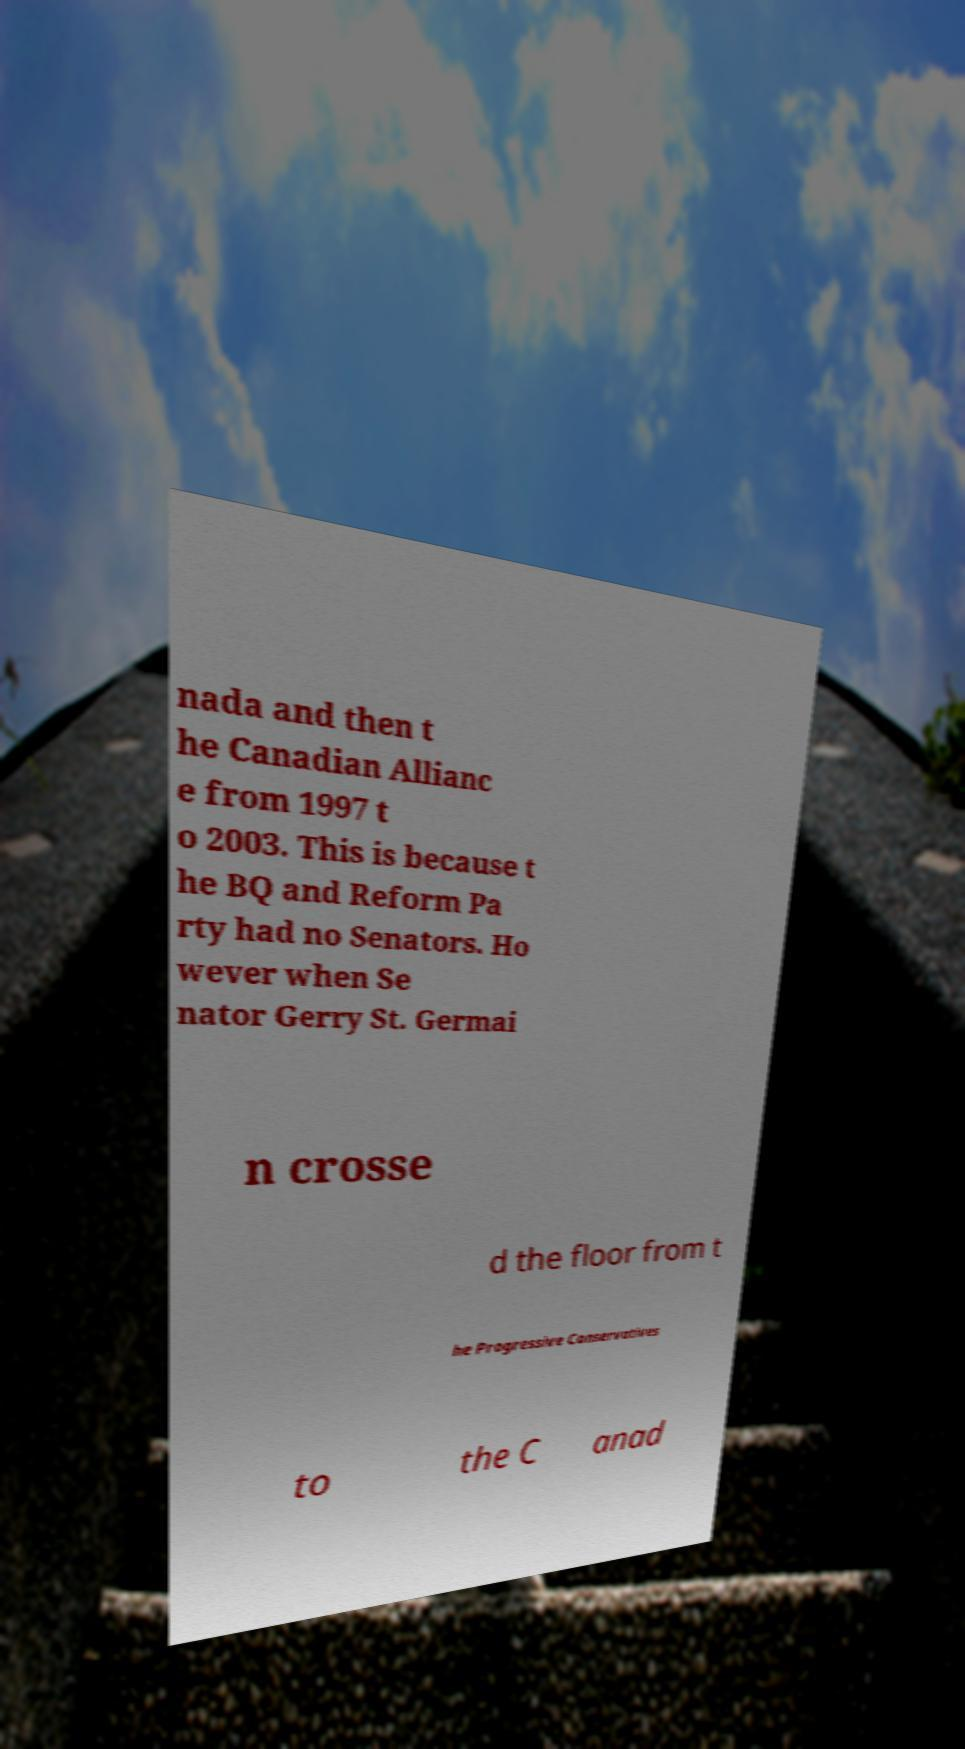For documentation purposes, I need the text within this image transcribed. Could you provide that? nada and then t he Canadian Allianc e from 1997 t o 2003. This is because t he BQ and Reform Pa rty had no Senators. Ho wever when Se nator Gerry St. Germai n crosse d the floor from t he Progressive Conservatives to the C anad 